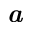Convert formula to latex. <formula><loc_0><loc_0><loc_500><loc_500>\em a</formula> 